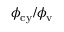<formula> <loc_0><loc_0><loc_500><loc_500>\phi _ { c y } / \phi _ { v }</formula> 